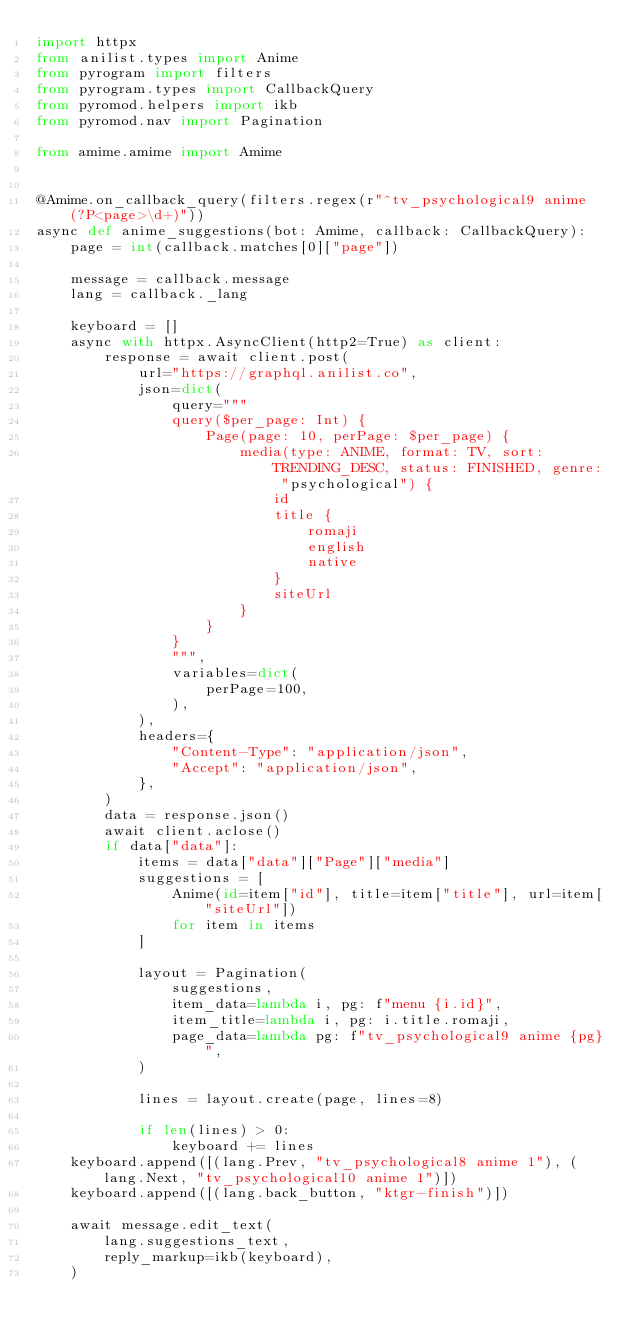Convert code to text. <code><loc_0><loc_0><loc_500><loc_500><_Python_>import httpx
from anilist.types import Anime
from pyrogram import filters
from pyrogram.types import CallbackQuery
from pyromod.helpers import ikb
from pyromod.nav import Pagination

from amime.amime import Amime


@Amime.on_callback_query(filters.regex(r"^tv_psychological9 anime (?P<page>\d+)"))
async def anime_suggestions(bot: Amime, callback: CallbackQuery):
    page = int(callback.matches[0]["page"])

    message = callback.message
    lang = callback._lang

    keyboard = []
    async with httpx.AsyncClient(http2=True) as client:
        response = await client.post(
            url="https://graphql.anilist.co",
            json=dict(
                query="""
                query($per_page: Int) {
                    Page(page: 10, perPage: $per_page) {
                        media(type: ANIME, format: TV, sort: TRENDING_DESC, status: FINISHED, genre: "psychological") {
                            id
                            title {
                                romaji
                                english
                                native
                            }
                            siteUrl
                        }
                    }
                }
                """,
                variables=dict(
                    perPage=100,
                ),
            ),
            headers={
                "Content-Type": "application/json",
                "Accept": "application/json",
            },
        )
        data = response.json()
        await client.aclose()
        if data["data"]:
            items = data["data"]["Page"]["media"]
            suggestions = [
                Anime(id=item["id"], title=item["title"], url=item["siteUrl"])
                for item in items
            ]

            layout = Pagination(
                suggestions,
                item_data=lambda i, pg: f"menu {i.id}",
                item_title=lambda i, pg: i.title.romaji,
                page_data=lambda pg: f"tv_psychological9 anime {pg}",
            )

            lines = layout.create(page, lines=8)

            if len(lines) > 0:
                keyboard += lines
    keyboard.append([(lang.Prev, "tv_psychological8 anime 1"), (lang.Next, "tv_psychological10 anime 1")])
    keyboard.append([(lang.back_button, "ktgr-finish")])

    await message.edit_text(
        lang.suggestions_text,
        reply_markup=ikb(keyboard),
    )
</code> 